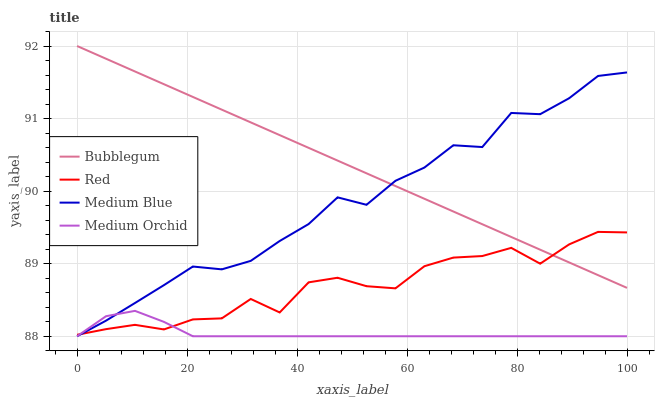Does Medium Blue have the minimum area under the curve?
Answer yes or no. No. Does Medium Blue have the maximum area under the curve?
Answer yes or no. No. Is Medium Blue the smoothest?
Answer yes or no. No. Is Medium Blue the roughest?
Answer yes or no. No. Does Red have the lowest value?
Answer yes or no. No. Does Medium Blue have the highest value?
Answer yes or no. No. Is Medium Orchid less than Bubblegum?
Answer yes or no. Yes. Is Bubblegum greater than Medium Orchid?
Answer yes or no. Yes. Does Medium Orchid intersect Bubblegum?
Answer yes or no. No. 